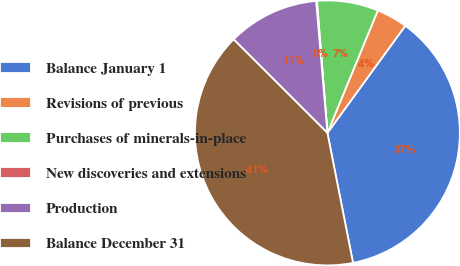Convert chart to OTSL. <chart><loc_0><loc_0><loc_500><loc_500><pie_chart><fcel>Balance January 1<fcel>Revisions of previous<fcel>Purchases of minerals-in-place<fcel>New discoveries and extensions<fcel>Production<fcel>Balance December 31<nl><fcel>36.9%<fcel>3.79%<fcel>7.47%<fcel>0.1%<fcel>11.16%<fcel>40.58%<nl></chart> 